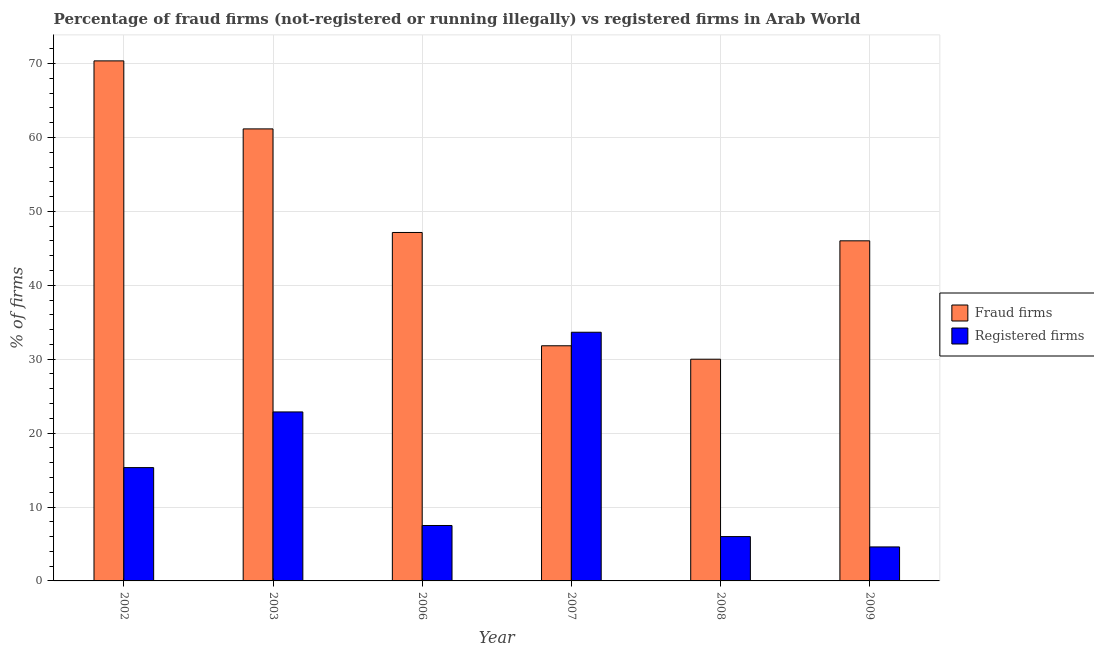Are the number of bars per tick equal to the number of legend labels?
Offer a very short reply. Yes. Are the number of bars on each tick of the X-axis equal?
Offer a very short reply. Yes. How many bars are there on the 2nd tick from the left?
Ensure brevity in your answer.  2. How many bars are there on the 3rd tick from the right?
Offer a very short reply. 2. What is the label of the 6th group of bars from the left?
Provide a short and direct response. 2009. In how many cases, is the number of bars for a given year not equal to the number of legend labels?
Provide a succinct answer. 0. What is the percentage of fraud firms in 2008?
Provide a succinct answer. 30. Across all years, what is the maximum percentage of registered firms?
Your answer should be very brief. 33.65. What is the total percentage of fraud firms in the graph?
Provide a short and direct response. 286.52. What is the difference between the percentage of registered firms in 2007 and that in 2008?
Ensure brevity in your answer.  27.65. What is the difference between the percentage of registered firms in 2009 and the percentage of fraud firms in 2008?
Your answer should be compact. -1.4. What is the average percentage of fraud firms per year?
Provide a short and direct response. 47.75. What is the ratio of the percentage of registered firms in 2002 to that in 2006?
Offer a very short reply. 2.04. Is the percentage of registered firms in 2002 less than that in 2006?
Your answer should be compact. No. What is the difference between the highest and the second highest percentage of fraud firms?
Your answer should be very brief. 9.21. What is the difference between the highest and the lowest percentage of registered firms?
Offer a terse response. 29.05. What does the 2nd bar from the left in 2006 represents?
Provide a short and direct response. Registered firms. What does the 2nd bar from the right in 2009 represents?
Your response must be concise. Fraud firms. What is the difference between two consecutive major ticks on the Y-axis?
Give a very brief answer. 10. Where does the legend appear in the graph?
Your answer should be compact. Center right. How many legend labels are there?
Provide a succinct answer. 2. How are the legend labels stacked?
Provide a succinct answer. Vertical. What is the title of the graph?
Provide a short and direct response. Percentage of fraud firms (not-registered or running illegally) vs registered firms in Arab World. What is the label or title of the X-axis?
Your response must be concise. Year. What is the label or title of the Y-axis?
Keep it short and to the point. % of firms. What is the % of firms in Fraud firms in 2002?
Provide a short and direct response. 70.37. What is the % of firms of Registered firms in 2002?
Your answer should be compact. 15.33. What is the % of firms of Fraud firms in 2003?
Offer a very short reply. 61.16. What is the % of firms in Registered firms in 2003?
Provide a short and direct response. 22.87. What is the % of firms in Fraud firms in 2006?
Your response must be concise. 47.15. What is the % of firms in Fraud firms in 2007?
Give a very brief answer. 31.82. What is the % of firms in Registered firms in 2007?
Keep it short and to the point. 33.65. What is the % of firms of Registered firms in 2008?
Your answer should be compact. 6. What is the % of firms of Fraud firms in 2009?
Ensure brevity in your answer.  46.02. Across all years, what is the maximum % of firms of Fraud firms?
Your answer should be very brief. 70.37. Across all years, what is the maximum % of firms in Registered firms?
Offer a terse response. 33.65. What is the total % of firms in Fraud firms in the graph?
Provide a succinct answer. 286.52. What is the total % of firms in Registered firms in the graph?
Offer a terse response. 89.95. What is the difference between the % of firms in Fraud firms in 2002 and that in 2003?
Provide a succinct answer. 9.21. What is the difference between the % of firms of Registered firms in 2002 and that in 2003?
Ensure brevity in your answer.  -7.53. What is the difference between the % of firms of Fraud firms in 2002 and that in 2006?
Offer a very short reply. 23.22. What is the difference between the % of firms in Registered firms in 2002 and that in 2006?
Your response must be concise. 7.83. What is the difference between the % of firms in Fraud firms in 2002 and that in 2007?
Offer a terse response. 38.55. What is the difference between the % of firms of Registered firms in 2002 and that in 2007?
Make the answer very short. -18.32. What is the difference between the % of firms in Fraud firms in 2002 and that in 2008?
Keep it short and to the point. 40.37. What is the difference between the % of firms in Registered firms in 2002 and that in 2008?
Ensure brevity in your answer.  9.33. What is the difference between the % of firms of Fraud firms in 2002 and that in 2009?
Offer a very short reply. 24.35. What is the difference between the % of firms in Registered firms in 2002 and that in 2009?
Keep it short and to the point. 10.73. What is the difference between the % of firms of Fraud firms in 2003 and that in 2006?
Provide a short and direct response. 14.02. What is the difference between the % of firms of Registered firms in 2003 and that in 2006?
Provide a succinct answer. 15.37. What is the difference between the % of firms in Fraud firms in 2003 and that in 2007?
Your answer should be very brief. 29.34. What is the difference between the % of firms in Registered firms in 2003 and that in 2007?
Your answer should be compact. -10.78. What is the difference between the % of firms in Fraud firms in 2003 and that in 2008?
Give a very brief answer. 31.16. What is the difference between the % of firms in Registered firms in 2003 and that in 2008?
Make the answer very short. 16.87. What is the difference between the % of firms of Fraud firms in 2003 and that in 2009?
Your answer should be compact. 15.14. What is the difference between the % of firms of Registered firms in 2003 and that in 2009?
Make the answer very short. 18.27. What is the difference between the % of firms in Fraud firms in 2006 and that in 2007?
Your response must be concise. 15.33. What is the difference between the % of firms in Registered firms in 2006 and that in 2007?
Make the answer very short. -26.15. What is the difference between the % of firms in Fraud firms in 2006 and that in 2008?
Keep it short and to the point. 17.15. What is the difference between the % of firms of Fraud firms in 2006 and that in 2009?
Your answer should be compact. 1.13. What is the difference between the % of firms of Fraud firms in 2007 and that in 2008?
Ensure brevity in your answer.  1.82. What is the difference between the % of firms in Registered firms in 2007 and that in 2008?
Provide a succinct answer. 27.65. What is the difference between the % of firms in Fraud firms in 2007 and that in 2009?
Your response must be concise. -14.2. What is the difference between the % of firms of Registered firms in 2007 and that in 2009?
Offer a very short reply. 29.05. What is the difference between the % of firms in Fraud firms in 2008 and that in 2009?
Your answer should be very brief. -16.02. What is the difference between the % of firms in Registered firms in 2008 and that in 2009?
Your answer should be compact. 1.4. What is the difference between the % of firms in Fraud firms in 2002 and the % of firms in Registered firms in 2003?
Provide a succinct answer. 47.5. What is the difference between the % of firms of Fraud firms in 2002 and the % of firms of Registered firms in 2006?
Your answer should be very brief. 62.87. What is the difference between the % of firms of Fraud firms in 2002 and the % of firms of Registered firms in 2007?
Offer a very short reply. 36.72. What is the difference between the % of firms of Fraud firms in 2002 and the % of firms of Registered firms in 2008?
Provide a short and direct response. 64.37. What is the difference between the % of firms of Fraud firms in 2002 and the % of firms of Registered firms in 2009?
Give a very brief answer. 65.77. What is the difference between the % of firms in Fraud firms in 2003 and the % of firms in Registered firms in 2006?
Your response must be concise. 53.66. What is the difference between the % of firms of Fraud firms in 2003 and the % of firms of Registered firms in 2007?
Provide a short and direct response. 27.52. What is the difference between the % of firms in Fraud firms in 2003 and the % of firms in Registered firms in 2008?
Ensure brevity in your answer.  55.16. What is the difference between the % of firms in Fraud firms in 2003 and the % of firms in Registered firms in 2009?
Provide a succinct answer. 56.56. What is the difference between the % of firms in Fraud firms in 2006 and the % of firms in Registered firms in 2008?
Your answer should be compact. 41.15. What is the difference between the % of firms in Fraud firms in 2006 and the % of firms in Registered firms in 2009?
Provide a succinct answer. 42.55. What is the difference between the % of firms of Fraud firms in 2007 and the % of firms of Registered firms in 2008?
Keep it short and to the point. 25.82. What is the difference between the % of firms of Fraud firms in 2007 and the % of firms of Registered firms in 2009?
Your answer should be very brief. 27.22. What is the difference between the % of firms of Fraud firms in 2008 and the % of firms of Registered firms in 2009?
Keep it short and to the point. 25.4. What is the average % of firms in Fraud firms per year?
Make the answer very short. 47.75. What is the average % of firms in Registered firms per year?
Offer a very short reply. 14.99. In the year 2002, what is the difference between the % of firms of Fraud firms and % of firms of Registered firms?
Give a very brief answer. 55.04. In the year 2003, what is the difference between the % of firms of Fraud firms and % of firms of Registered firms?
Your response must be concise. 38.3. In the year 2006, what is the difference between the % of firms in Fraud firms and % of firms in Registered firms?
Offer a terse response. 39.65. In the year 2007, what is the difference between the % of firms in Fraud firms and % of firms in Registered firms?
Offer a very short reply. -1.83. In the year 2008, what is the difference between the % of firms in Fraud firms and % of firms in Registered firms?
Your answer should be very brief. 24. In the year 2009, what is the difference between the % of firms of Fraud firms and % of firms of Registered firms?
Give a very brief answer. 41.42. What is the ratio of the % of firms in Fraud firms in 2002 to that in 2003?
Make the answer very short. 1.15. What is the ratio of the % of firms of Registered firms in 2002 to that in 2003?
Provide a short and direct response. 0.67. What is the ratio of the % of firms in Fraud firms in 2002 to that in 2006?
Make the answer very short. 1.49. What is the ratio of the % of firms in Registered firms in 2002 to that in 2006?
Give a very brief answer. 2.04. What is the ratio of the % of firms of Fraud firms in 2002 to that in 2007?
Provide a short and direct response. 2.21. What is the ratio of the % of firms in Registered firms in 2002 to that in 2007?
Keep it short and to the point. 0.46. What is the ratio of the % of firms in Fraud firms in 2002 to that in 2008?
Your answer should be compact. 2.35. What is the ratio of the % of firms of Registered firms in 2002 to that in 2008?
Give a very brief answer. 2.56. What is the ratio of the % of firms in Fraud firms in 2002 to that in 2009?
Keep it short and to the point. 1.53. What is the ratio of the % of firms in Fraud firms in 2003 to that in 2006?
Offer a very short reply. 1.3. What is the ratio of the % of firms in Registered firms in 2003 to that in 2006?
Provide a short and direct response. 3.05. What is the ratio of the % of firms in Fraud firms in 2003 to that in 2007?
Your answer should be very brief. 1.92. What is the ratio of the % of firms in Registered firms in 2003 to that in 2007?
Make the answer very short. 0.68. What is the ratio of the % of firms of Fraud firms in 2003 to that in 2008?
Your response must be concise. 2.04. What is the ratio of the % of firms in Registered firms in 2003 to that in 2008?
Your answer should be very brief. 3.81. What is the ratio of the % of firms in Fraud firms in 2003 to that in 2009?
Provide a succinct answer. 1.33. What is the ratio of the % of firms of Registered firms in 2003 to that in 2009?
Make the answer very short. 4.97. What is the ratio of the % of firms in Fraud firms in 2006 to that in 2007?
Provide a succinct answer. 1.48. What is the ratio of the % of firms of Registered firms in 2006 to that in 2007?
Ensure brevity in your answer.  0.22. What is the ratio of the % of firms of Fraud firms in 2006 to that in 2008?
Offer a terse response. 1.57. What is the ratio of the % of firms in Fraud firms in 2006 to that in 2009?
Ensure brevity in your answer.  1.02. What is the ratio of the % of firms of Registered firms in 2006 to that in 2009?
Offer a terse response. 1.63. What is the ratio of the % of firms of Fraud firms in 2007 to that in 2008?
Your answer should be very brief. 1.06. What is the ratio of the % of firms in Registered firms in 2007 to that in 2008?
Offer a very short reply. 5.61. What is the ratio of the % of firms of Fraud firms in 2007 to that in 2009?
Your answer should be compact. 0.69. What is the ratio of the % of firms of Registered firms in 2007 to that in 2009?
Ensure brevity in your answer.  7.32. What is the ratio of the % of firms in Fraud firms in 2008 to that in 2009?
Give a very brief answer. 0.65. What is the ratio of the % of firms in Registered firms in 2008 to that in 2009?
Offer a very short reply. 1.3. What is the difference between the highest and the second highest % of firms in Fraud firms?
Provide a succinct answer. 9.21. What is the difference between the highest and the second highest % of firms in Registered firms?
Offer a very short reply. 10.78. What is the difference between the highest and the lowest % of firms in Fraud firms?
Your response must be concise. 40.37. What is the difference between the highest and the lowest % of firms of Registered firms?
Offer a terse response. 29.05. 